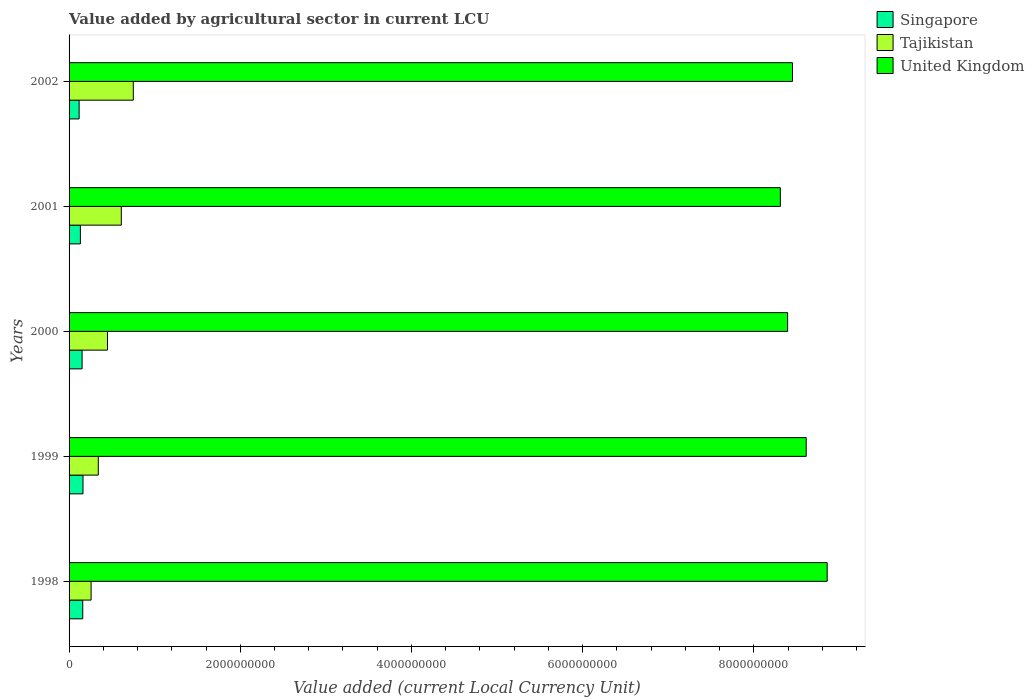How many different coloured bars are there?
Give a very brief answer. 3. Are the number of bars per tick equal to the number of legend labels?
Provide a succinct answer. Yes. Are the number of bars on each tick of the Y-axis equal?
Give a very brief answer. Yes. How many bars are there on the 5th tick from the bottom?
Your response must be concise. 3. What is the label of the 5th group of bars from the top?
Provide a succinct answer. 1998. What is the value added by agricultural sector in Tajikistan in 2001?
Ensure brevity in your answer.  6.10e+08. Across all years, what is the maximum value added by agricultural sector in United Kingdom?
Your answer should be very brief. 8.86e+09. Across all years, what is the minimum value added by agricultural sector in Singapore?
Provide a short and direct response. 1.17e+08. In which year was the value added by agricultural sector in Tajikistan maximum?
Ensure brevity in your answer.  2002. What is the total value added by agricultural sector in Singapore in the graph?
Provide a succinct answer. 7.24e+08. What is the difference between the value added by agricultural sector in Tajikistan in 1999 and that in 2000?
Your answer should be very brief. -1.07e+08. What is the difference between the value added by agricultural sector in Singapore in 1999 and the value added by agricultural sector in Tajikistan in 2001?
Give a very brief answer. -4.48e+08. What is the average value added by agricultural sector in Singapore per year?
Offer a very short reply. 1.45e+08. In the year 2001, what is the difference between the value added by agricultural sector in United Kingdom and value added by agricultural sector in Singapore?
Your response must be concise. 8.18e+09. What is the ratio of the value added by agricultural sector in Tajikistan in 1998 to that in 2001?
Your response must be concise. 0.42. Is the difference between the value added by agricultural sector in United Kingdom in 1998 and 2000 greater than the difference between the value added by agricultural sector in Singapore in 1998 and 2000?
Make the answer very short. Yes. What is the difference between the highest and the second highest value added by agricultural sector in Tajikistan?
Give a very brief answer. 1.40e+08. What is the difference between the highest and the lowest value added by agricultural sector in Singapore?
Provide a short and direct response. 4.53e+07. In how many years, is the value added by agricultural sector in Singapore greater than the average value added by agricultural sector in Singapore taken over all years?
Ensure brevity in your answer.  3. What does the 2nd bar from the top in 2001 represents?
Make the answer very short. Tajikistan. What does the 2nd bar from the bottom in 1999 represents?
Offer a very short reply. Tajikistan. Is it the case that in every year, the sum of the value added by agricultural sector in Singapore and value added by agricultural sector in Tajikistan is greater than the value added by agricultural sector in United Kingdom?
Keep it short and to the point. No. Does the graph contain any zero values?
Offer a very short reply. No. Where does the legend appear in the graph?
Ensure brevity in your answer.  Top right. What is the title of the graph?
Make the answer very short. Value added by agricultural sector in current LCU. Does "Honduras" appear as one of the legend labels in the graph?
Provide a short and direct response. No. What is the label or title of the X-axis?
Provide a succinct answer. Value added (current Local Currency Unit). What is the Value added (current Local Currency Unit) of Singapore in 1998?
Provide a short and direct response. 1.60e+08. What is the Value added (current Local Currency Unit) of Tajikistan in 1998?
Ensure brevity in your answer.  2.57e+08. What is the Value added (current Local Currency Unit) in United Kingdom in 1998?
Your response must be concise. 8.86e+09. What is the Value added (current Local Currency Unit) in Singapore in 1999?
Offer a very short reply. 1.63e+08. What is the Value added (current Local Currency Unit) in Tajikistan in 1999?
Offer a very short reply. 3.41e+08. What is the Value added (current Local Currency Unit) in United Kingdom in 1999?
Your response must be concise. 8.61e+09. What is the Value added (current Local Currency Unit) of Singapore in 2000?
Provide a succinct answer. 1.52e+08. What is the Value added (current Local Currency Unit) in Tajikistan in 2000?
Keep it short and to the point. 4.49e+08. What is the Value added (current Local Currency Unit) in United Kingdom in 2000?
Offer a very short reply. 8.40e+09. What is the Value added (current Local Currency Unit) of Singapore in 2001?
Your answer should be very brief. 1.32e+08. What is the Value added (current Local Currency Unit) of Tajikistan in 2001?
Offer a very short reply. 6.10e+08. What is the Value added (current Local Currency Unit) of United Kingdom in 2001?
Your response must be concise. 8.31e+09. What is the Value added (current Local Currency Unit) of Singapore in 2002?
Keep it short and to the point. 1.17e+08. What is the Value added (current Local Currency Unit) of Tajikistan in 2002?
Your answer should be compact. 7.50e+08. What is the Value added (current Local Currency Unit) of United Kingdom in 2002?
Your answer should be very brief. 8.45e+09. Across all years, what is the maximum Value added (current Local Currency Unit) in Singapore?
Your answer should be compact. 1.63e+08. Across all years, what is the maximum Value added (current Local Currency Unit) of Tajikistan?
Provide a succinct answer. 7.50e+08. Across all years, what is the maximum Value added (current Local Currency Unit) in United Kingdom?
Your answer should be very brief. 8.86e+09. Across all years, what is the minimum Value added (current Local Currency Unit) in Singapore?
Offer a terse response. 1.17e+08. Across all years, what is the minimum Value added (current Local Currency Unit) of Tajikistan?
Give a very brief answer. 2.57e+08. Across all years, what is the minimum Value added (current Local Currency Unit) of United Kingdom?
Make the answer very short. 8.31e+09. What is the total Value added (current Local Currency Unit) in Singapore in the graph?
Your answer should be compact. 7.24e+08. What is the total Value added (current Local Currency Unit) in Tajikistan in the graph?
Your answer should be compact. 2.41e+09. What is the total Value added (current Local Currency Unit) in United Kingdom in the graph?
Ensure brevity in your answer.  4.26e+1. What is the difference between the Value added (current Local Currency Unit) of Singapore in 1998 and that in 1999?
Your answer should be compact. -2.90e+06. What is the difference between the Value added (current Local Currency Unit) in Tajikistan in 1998 and that in 1999?
Keep it short and to the point. -8.41e+07. What is the difference between the Value added (current Local Currency Unit) of United Kingdom in 1998 and that in 1999?
Your answer should be compact. 2.45e+08. What is the difference between the Value added (current Local Currency Unit) of Singapore in 1998 and that in 2000?
Your answer should be compact. 7.60e+06. What is the difference between the Value added (current Local Currency Unit) of Tajikistan in 1998 and that in 2000?
Offer a terse response. -1.92e+08. What is the difference between the Value added (current Local Currency Unit) in United Kingdom in 1998 and that in 2000?
Offer a very short reply. 4.62e+08. What is the difference between the Value added (current Local Currency Unit) in Singapore in 1998 and that in 2001?
Provide a short and direct response. 2.76e+07. What is the difference between the Value added (current Local Currency Unit) of Tajikistan in 1998 and that in 2001?
Offer a very short reply. -3.53e+08. What is the difference between the Value added (current Local Currency Unit) of United Kingdom in 1998 and that in 2001?
Your answer should be compact. 5.47e+08. What is the difference between the Value added (current Local Currency Unit) of Singapore in 1998 and that in 2002?
Offer a very short reply. 4.24e+07. What is the difference between the Value added (current Local Currency Unit) in Tajikistan in 1998 and that in 2002?
Offer a terse response. -4.93e+08. What is the difference between the Value added (current Local Currency Unit) in United Kingdom in 1998 and that in 2002?
Offer a terse response. 4.05e+08. What is the difference between the Value added (current Local Currency Unit) of Singapore in 1999 and that in 2000?
Give a very brief answer. 1.05e+07. What is the difference between the Value added (current Local Currency Unit) in Tajikistan in 1999 and that in 2000?
Keep it short and to the point. -1.07e+08. What is the difference between the Value added (current Local Currency Unit) in United Kingdom in 1999 and that in 2000?
Your answer should be very brief. 2.17e+08. What is the difference between the Value added (current Local Currency Unit) of Singapore in 1999 and that in 2001?
Provide a succinct answer. 3.05e+07. What is the difference between the Value added (current Local Currency Unit) of Tajikistan in 1999 and that in 2001?
Your response must be concise. -2.69e+08. What is the difference between the Value added (current Local Currency Unit) of United Kingdom in 1999 and that in 2001?
Your answer should be compact. 3.02e+08. What is the difference between the Value added (current Local Currency Unit) of Singapore in 1999 and that in 2002?
Offer a terse response. 4.53e+07. What is the difference between the Value added (current Local Currency Unit) in Tajikistan in 1999 and that in 2002?
Provide a succinct answer. -4.09e+08. What is the difference between the Value added (current Local Currency Unit) in United Kingdom in 1999 and that in 2002?
Keep it short and to the point. 1.60e+08. What is the difference between the Value added (current Local Currency Unit) of Singapore in 2000 and that in 2001?
Offer a terse response. 2.00e+07. What is the difference between the Value added (current Local Currency Unit) in Tajikistan in 2000 and that in 2001?
Your response must be concise. -1.61e+08. What is the difference between the Value added (current Local Currency Unit) of United Kingdom in 2000 and that in 2001?
Offer a very short reply. 8.50e+07. What is the difference between the Value added (current Local Currency Unit) of Singapore in 2000 and that in 2002?
Keep it short and to the point. 3.48e+07. What is the difference between the Value added (current Local Currency Unit) in Tajikistan in 2000 and that in 2002?
Ensure brevity in your answer.  -3.01e+08. What is the difference between the Value added (current Local Currency Unit) of United Kingdom in 2000 and that in 2002?
Offer a very short reply. -5.70e+07. What is the difference between the Value added (current Local Currency Unit) of Singapore in 2001 and that in 2002?
Ensure brevity in your answer.  1.48e+07. What is the difference between the Value added (current Local Currency Unit) of Tajikistan in 2001 and that in 2002?
Your response must be concise. -1.40e+08. What is the difference between the Value added (current Local Currency Unit) in United Kingdom in 2001 and that in 2002?
Ensure brevity in your answer.  -1.42e+08. What is the difference between the Value added (current Local Currency Unit) of Singapore in 1998 and the Value added (current Local Currency Unit) of Tajikistan in 1999?
Provide a short and direct response. -1.82e+08. What is the difference between the Value added (current Local Currency Unit) in Singapore in 1998 and the Value added (current Local Currency Unit) in United Kingdom in 1999?
Give a very brief answer. -8.45e+09. What is the difference between the Value added (current Local Currency Unit) of Tajikistan in 1998 and the Value added (current Local Currency Unit) of United Kingdom in 1999?
Offer a very short reply. -8.35e+09. What is the difference between the Value added (current Local Currency Unit) in Singapore in 1998 and the Value added (current Local Currency Unit) in Tajikistan in 2000?
Keep it short and to the point. -2.89e+08. What is the difference between the Value added (current Local Currency Unit) of Singapore in 1998 and the Value added (current Local Currency Unit) of United Kingdom in 2000?
Ensure brevity in your answer.  -8.24e+09. What is the difference between the Value added (current Local Currency Unit) in Tajikistan in 1998 and the Value added (current Local Currency Unit) in United Kingdom in 2000?
Your response must be concise. -8.14e+09. What is the difference between the Value added (current Local Currency Unit) of Singapore in 1998 and the Value added (current Local Currency Unit) of Tajikistan in 2001?
Offer a very short reply. -4.51e+08. What is the difference between the Value added (current Local Currency Unit) in Singapore in 1998 and the Value added (current Local Currency Unit) in United Kingdom in 2001?
Your response must be concise. -8.15e+09. What is the difference between the Value added (current Local Currency Unit) in Tajikistan in 1998 and the Value added (current Local Currency Unit) in United Kingdom in 2001?
Your answer should be compact. -8.05e+09. What is the difference between the Value added (current Local Currency Unit) in Singapore in 1998 and the Value added (current Local Currency Unit) in Tajikistan in 2002?
Keep it short and to the point. -5.91e+08. What is the difference between the Value added (current Local Currency Unit) in Singapore in 1998 and the Value added (current Local Currency Unit) in United Kingdom in 2002?
Your answer should be very brief. -8.29e+09. What is the difference between the Value added (current Local Currency Unit) in Tajikistan in 1998 and the Value added (current Local Currency Unit) in United Kingdom in 2002?
Your answer should be very brief. -8.19e+09. What is the difference between the Value added (current Local Currency Unit) of Singapore in 1999 and the Value added (current Local Currency Unit) of Tajikistan in 2000?
Provide a succinct answer. -2.86e+08. What is the difference between the Value added (current Local Currency Unit) of Singapore in 1999 and the Value added (current Local Currency Unit) of United Kingdom in 2000?
Provide a succinct answer. -8.23e+09. What is the difference between the Value added (current Local Currency Unit) in Tajikistan in 1999 and the Value added (current Local Currency Unit) in United Kingdom in 2000?
Your answer should be very brief. -8.05e+09. What is the difference between the Value added (current Local Currency Unit) of Singapore in 1999 and the Value added (current Local Currency Unit) of Tajikistan in 2001?
Your answer should be compact. -4.48e+08. What is the difference between the Value added (current Local Currency Unit) in Singapore in 1999 and the Value added (current Local Currency Unit) in United Kingdom in 2001?
Offer a terse response. -8.15e+09. What is the difference between the Value added (current Local Currency Unit) of Tajikistan in 1999 and the Value added (current Local Currency Unit) of United Kingdom in 2001?
Your answer should be compact. -7.97e+09. What is the difference between the Value added (current Local Currency Unit) in Singapore in 1999 and the Value added (current Local Currency Unit) in Tajikistan in 2002?
Provide a short and direct response. -5.88e+08. What is the difference between the Value added (current Local Currency Unit) of Singapore in 1999 and the Value added (current Local Currency Unit) of United Kingdom in 2002?
Offer a very short reply. -8.29e+09. What is the difference between the Value added (current Local Currency Unit) of Tajikistan in 1999 and the Value added (current Local Currency Unit) of United Kingdom in 2002?
Offer a terse response. -8.11e+09. What is the difference between the Value added (current Local Currency Unit) in Singapore in 2000 and the Value added (current Local Currency Unit) in Tajikistan in 2001?
Provide a short and direct response. -4.58e+08. What is the difference between the Value added (current Local Currency Unit) of Singapore in 2000 and the Value added (current Local Currency Unit) of United Kingdom in 2001?
Offer a terse response. -8.16e+09. What is the difference between the Value added (current Local Currency Unit) of Tajikistan in 2000 and the Value added (current Local Currency Unit) of United Kingdom in 2001?
Ensure brevity in your answer.  -7.86e+09. What is the difference between the Value added (current Local Currency Unit) in Singapore in 2000 and the Value added (current Local Currency Unit) in Tajikistan in 2002?
Offer a terse response. -5.98e+08. What is the difference between the Value added (current Local Currency Unit) in Singapore in 2000 and the Value added (current Local Currency Unit) in United Kingdom in 2002?
Your answer should be very brief. -8.30e+09. What is the difference between the Value added (current Local Currency Unit) of Tajikistan in 2000 and the Value added (current Local Currency Unit) of United Kingdom in 2002?
Your response must be concise. -8.00e+09. What is the difference between the Value added (current Local Currency Unit) of Singapore in 2001 and the Value added (current Local Currency Unit) of Tajikistan in 2002?
Make the answer very short. -6.18e+08. What is the difference between the Value added (current Local Currency Unit) in Singapore in 2001 and the Value added (current Local Currency Unit) in United Kingdom in 2002?
Your answer should be compact. -8.32e+09. What is the difference between the Value added (current Local Currency Unit) in Tajikistan in 2001 and the Value added (current Local Currency Unit) in United Kingdom in 2002?
Give a very brief answer. -7.84e+09. What is the average Value added (current Local Currency Unit) of Singapore per year?
Make the answer very short. 1.45e+08. What is the average Value added (current Local Currency Unit) in Tajikistan per year?
Your response must be concise. 4.82e+08. What is the average Value added (current Local Currency Unit) in United Kingdom per year?
Make the answer very short. 8.53e+09. In the year 1998, what is the difference between the Value added (current Local Currency Unit) in Singapore and Value added (current Local Currency Unit) in Tajikistan?
Your answer should be compact. -9.76e+07. In the year 1998, what is the difference between the Value added (current Local Currency Unit) in Singapore and Value added (current Local Currency Unit) in United Kingdom?
Ensure brevity in your answer.  -8.70e+09. In the year 1998, what is the difference between the Value added (current Local Currency Unit) of Tajikistan and Value added (current Local Currency Unit) of United Kingdom?
Your answer should be very brief. -8.60e+09. In the year 1999, what is the difference between the Value added (current Local Currency Unit) of Singapore and Value added (current Local Currency Unit) of Tajikistan?
Make the answer very short. -1.79e+08. In the year 1999, what is the difference between the Value added (current Local Currency Unit) of Singapore and Value added (current Local Currency Unit) of United Kingdom?
Keep it short and to the point. -8.45e+09. In the year 1999, what is the difference between the Value added (current Local Currency Unit) in Tajikistan and Value added (current Local Currency Unit) in United Kingdom?
Your answer should be compact. -8.27e+09. In the year 2000, what is the difference between the Value added (current Local Currency Unit) of Singapore and Value added (current Local Currency Unit) of Tajikistan?
Your response must be concise. -2.97e+08. In the year 2000, what is the difference between the Value added (current Local Currency Unit) in Singapore and Value added (current Local Currency Unit) in United Kingdom?
Make the answer very short. -8.24e+09. In the year 2000, what is the difference between the Value added (current Local Currency Unit) of Tajikistan and Value added (current Local Currency Unit) of United Kingdom?
Make the answer very short. -7.95e+09. In the year 2001, what is the difference between the Value added (current Local Currency Unit) of Singapore and Value added (current Local Currency Unit) of Tajikistan?
Give a very brief answer. -4.78e+08. In the year 2001, what is the difference between the Value added (current Local Currency Unit) in Singapore and Value added (current Local Currency Unit) in United Kingdom?
Keep it short and to the point. -8.18e+09. In the year 2001, what is the difference between the Value added (current Local Currency Unit) in Tajikistan and Value added (current Local Currency Unit) in United Kingdom?
Your answer should be very brief. -7.70e+09. In the year 2002, what is the difference between the Value added (current Local Currency Unit) of Singapore and Value added (current Local Currency Unit) of Tajikistan?
Provide a short and direct response. -6.33e+08. In the year 2002, what is the difference between the Value added (current Local Currency Unit) in Singapore and Value added (current Local Currency Unit) in United Kingdom?
Your response must be concise. -8.33e+09. In the year 2002, what is the difference between the Value added (current Local Currency Unit) in Tajikistan and Value added (current Local Currency Unit) in United Kingdom?
Ensure brevity in your answer.  -7.70e+09. What is the ratio of the Value added (current Local Currency Unit) in Singapore in 1998 to that in 1999?
Make the answer very short. 0.98. What is the ratio of the Value added (current Local Currency Unit) of Tajikistan in 1998 to that in 1999?
Ensure brevity in your answer.  0.75. What is the ratio of the Value added (current Local Currency Unit) of United Kingdom in 1998 to that in 1999?
Your response must be concise. 1.03. What is the ratio of the Value added (current Local Currency Unit) in Singapore in 1998 to that in 2000?
Offer a terse response. 1.05. What is the ratio of the Value added (current Local Currency Unit) in Tajikistan in 1998 to that in 2000?
Keep it short and to the point. 0.57. What is the ratio of the Value added (current Local Currency Unit) of United Kingdom in 1998 to that in 2000?
Offer a terse response. 1.05. What is the ratio of the Value added (current Local Currency Unit) of Singapore in 1998 to that in 2001?
Keep it short and to the point. 1.21. What is the ratio of the Value added (current Local Currency Unit) of Tajikistan in 1998 to that in 2001?
Offer a terse response. 0.42. What is the ratio of the Value added (current Local Currency Unit) in United Kingdom in 1998 to that in 2001?
Provide a succinct answer. 1.07. What is the ratio of the Value added (current Local Currency Unit) of Singapore in 1998 to that in 2002?
Offer a terse response. 1.36. What is the ratio of the Value added (current Local Currency Unit) of Tajikistan in 1998 to that in 2002?
Keep it short and to the point. 0.34. What is the ratio of the Value added (current Local Currency Unit) in United Kingdom in 1998 to that in 2002?
Keep it short and to the point. 1.05. What is the ratio of the Value added (current Local Currency Unit) in Singapore in 1999 to that in 2000?
Keep it short and to the point. 1.07. What is the ratio of the Value added (current Local Currency Unit) in Tajikistan in 1999 to that in 2000?
Keep it short and to the point. 0.76. What is the ratio of the Value added (current Local Currency Unit) in United Kingdom in 1999 to that in 2000?
Your answer should be very brief. 1.03. What is the ratio of the Value added (current Local Currency Unit) in Singapore in 1999 to that in 2001?
Give a very brief answer. 1.23. What is the ratio of the Value added (current Local Currency Unit) of Tajikistan in 1999 to that in 2001?
Keep it short and to the point. 0.56. What is the ratio of the Value added (current Local Currency Unit) of United Kingdom in 1999 to that in 2001?
Offer a terse response. 1.04. What is the ratio of the Value added (current Local Currency Unit) of Singapore in 1999 to that in 2002?
Make the answer very short. 1.39. What is the ratio of the Value added (current Local Currency Unit) in Tajikistan in 1999 to that in 2002?
Make the answer very short. 0.46. What is the ratio of the Value added (current Local Currency Unit) in United Kingdom in 1999 to that in 2002?
Keep it short and to the point. 1.02. What is the ratio of the Value added (current Local Currency Unit) of Singapore in 2000 to that in 2001?
Give a very brief answer. 1.15. What is the ratio of the Value added (current Local Currency Unit) of Tajikistan in 2000 to that in 2001?
Keep it short and to the point. 0.74. What is the ratio of the Value added (current Local Currency Unit) in United Kingdom in 2000 to that in 2001?
Your answer should be compact. 1.01. What is the ratio of the Value added (current Local Currency Unit) of Singapore in 2000 to that in 2002?
Keep it short and to the point. 1.3. What is the ratio of the Value added (current Local Currency Unit) of Tajikistan in 2000 to that in 2002?
Give a very brief answer. 0.6. What is the ratio of the Value added (current Local Currency Unit) in Singapore in 2001 to that in 2002?
Ensure brevity in your answer.  1.13. What is the ratio of the Value added (current Local Currency Unit) in Tajikistan in 2001 to that in 2002?
Your answer should be compact. 0.81. What is the ratio of the Value added (current Local Currency Unit) in United Kingdom in 2001 to that in 2002?
Your answer should be very brief. 0.98. What is the difference between the highest and the second highest Value added (current Local Currency Unit) of Singapore?
Provide a short and direct response. 2.90e+06. What is the difference between the highest and the second highest Value added (current Local Currency Unit) in Tajikistan?
Offer a terse response. 1.40e+08. What is the difference between the highest and the second highest Value added (current Local Currency Unit) in United Kingdom?
Your answer should be compact. 2.45e+08. What is the difference between the highest and the lowest Value added (current Local Currency Unit) of Singapore?
Your answer should be very brief. 4.53e+07. What is the difference between the highest and the lowest Value added (current Local Currency Unit) in Tajikistan?
Offer a very short reply. 4.93e+08. What is the difference between the highest and the lowest Value added (current Local Currency Unit) in United Kingdom?
Keep it short and to the point. 5.47e+08. 